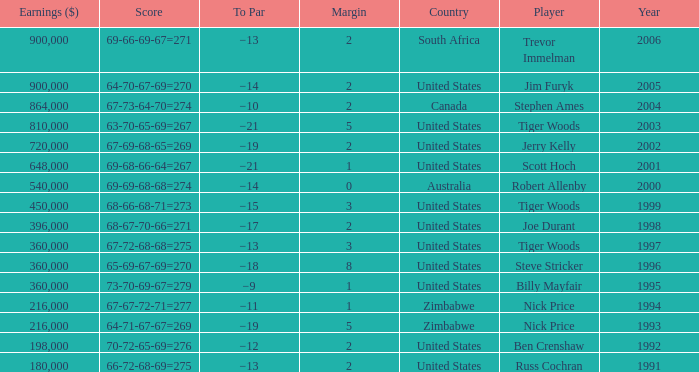How many years have a Player of joe durant, and Earnings ($) larger than 396,000? 0.0. 